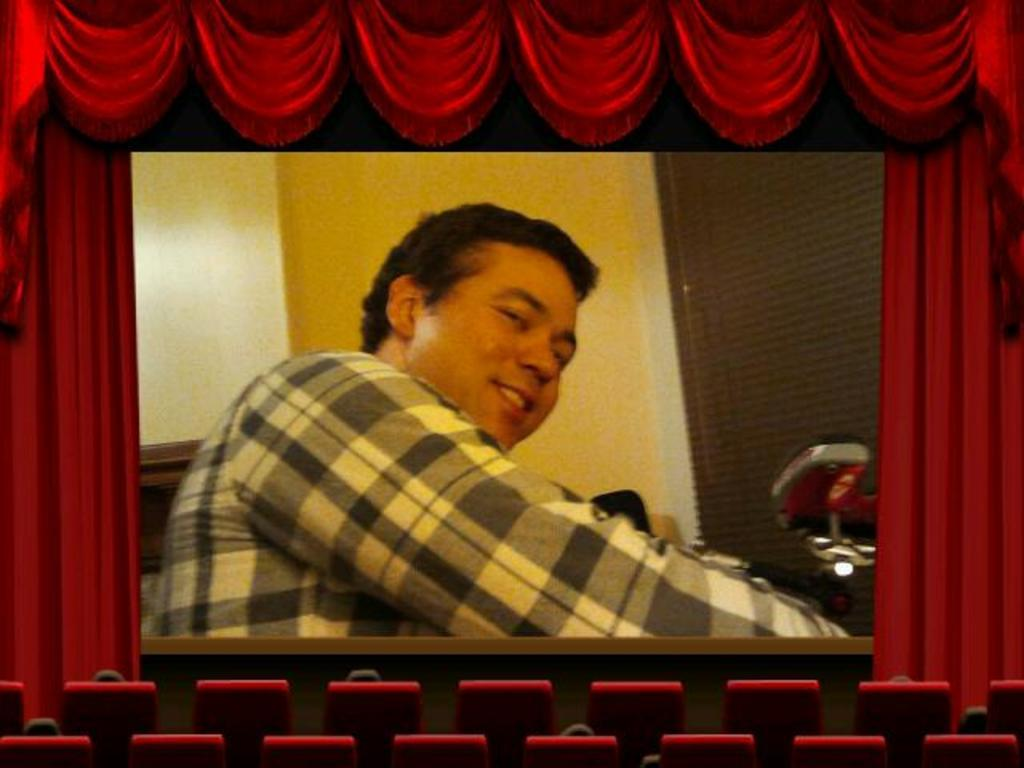What type of furniture is present in the image? There are chairs in the image. What can be seen on the screen in the image? There are objects on the screen in the image. What type of window treatment is visible in the image? There are curtains in the image. Can you describe the person's face in the image? A person's face is visible in the image. Can you tell me how many rabbits are visible on the screen in the image? There are no rabbits visible on the screen in the image. What type of voyage is the person taking in the image? There is no indication of a voyage in the image; it only shows a person's face, chairs, a screen, and curtains. 